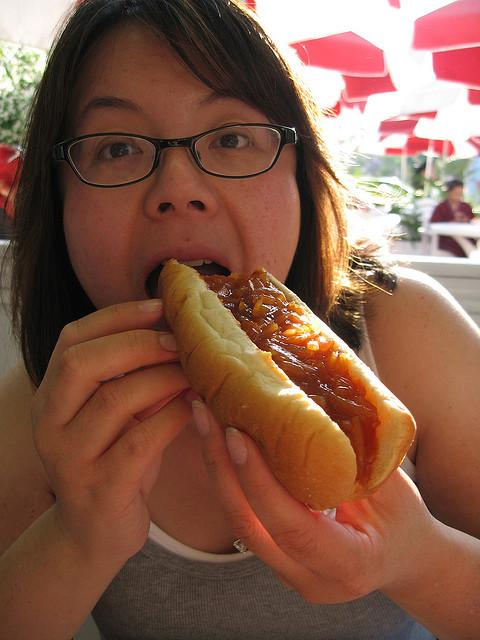What food is that bun normally used for? hotdog 